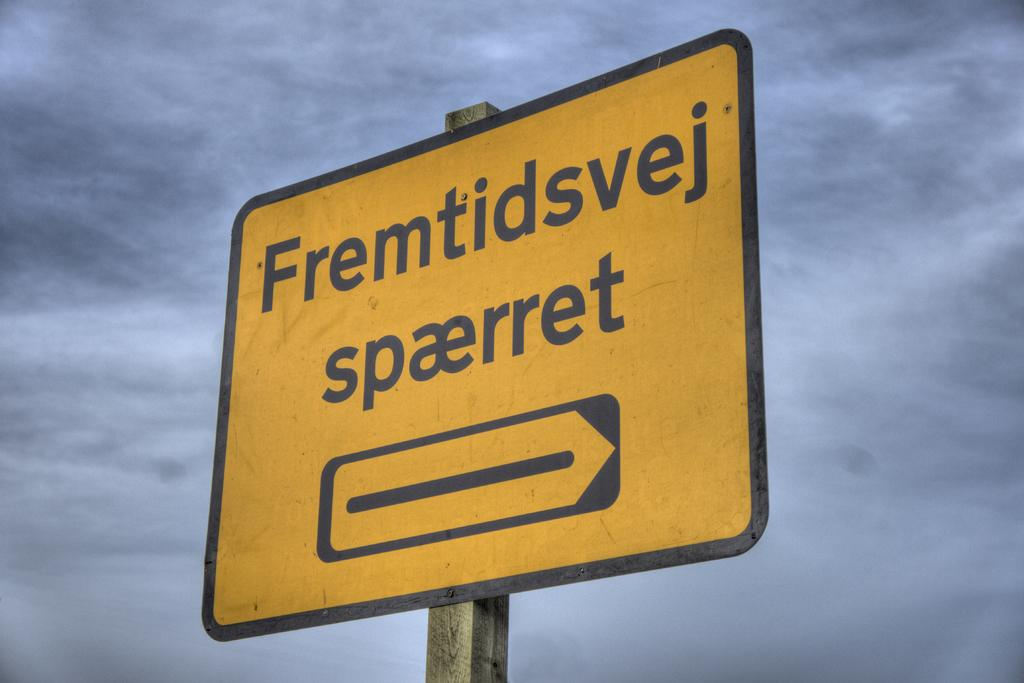<image>
Give a short and clear explanation of the subsequent image. the word spaerret is on a yellow sign 